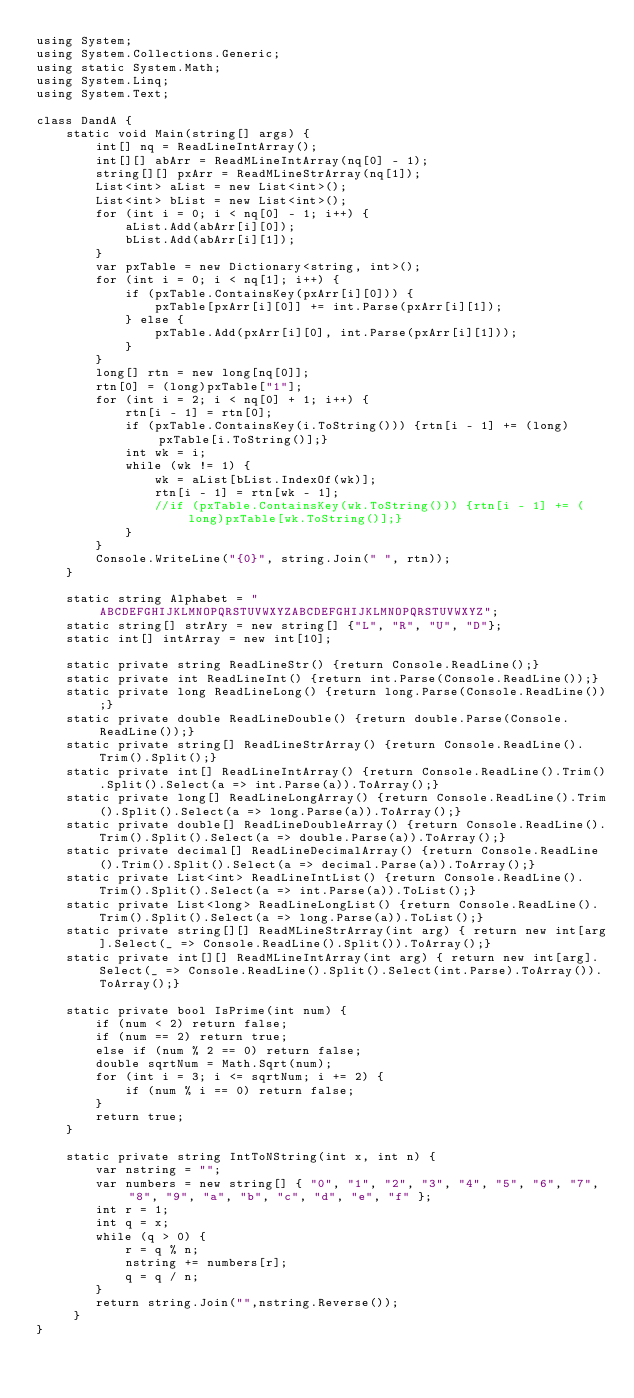Convert code to text. <code><loc_0><loc_0><loc_500><loc_500><_C#_>using System;
using System.Collections.Generic;
using static System.Math;
using System.Linq;
using System.Text;
 
class DandA {
    static void Main(string[] args) {
        int[] nq = ReadLineIntArray();
        int[][] abArr = ReadMLineIntArray(nq[0] - 1);
        string[][] pxArr = ReadMLineStrArray(nq[1]);
        List<int> aList = new List<int>();
        List<int> bList = new List<int>();
        for (int i = 0; i < nq[0] - 1; i++) {
            aList.Add(abArr[i][0]);
            bList.Add(abArr[i][1]);
        }
        var pxTable = new Dictionary<string, int>();
        for (int i = 0; i < nq[1]; i++) {
            if (pxTable.ContainsKey(pxArr[i][0])) {
                pxTable[pxArr[i][0]] += int.Parse(pxArr[i][1]);
            } else {
                pxTable.Add(pxArr[i][0], int.Parse(pxArr[i][1]));
            }
        }
        long[] rtn = new long[nq[0]];
        rtn[0] = (long)pxTable["1"];
        for (int i = 2; i < nq[0] + 1; i++) {
            rtn[i - 1] = rtn[0];
            if (pxTable.ContainsKey(i.ToString())) {rtn[i - 1] += (long)pxTable[i.ToString()];}
            int wk = i;
            while (wk != 1) {
                wk = aList[bList.IndexOf(wk)];
                rtn[i - 1] = rtn[wk - 1];
                //if (pxTable.ContainsKey(wk.ToString())) {rtn[i - 1] += (long)pxTable[wk.ToString()];}
            }
        }
        Console.WriteLine("{0}", string.Join(" ", rtn));
    }
 
    static string Alphabet = "ABCDEFGHIJKLMNOPQRSTUVWXYZABCDEFGHIJKLMNOPQRSTUVWXYZ";
    static string[] strAry = new string[] {"L", "R", "U", "D"};
    static int[] intArray = new int[10];
  
    static private string ReadLineStr() {return Console.ReadLine();}
    static private int ReadLineInt() {return int.Parse(Console.ReadLine());}
    static private long ReadLineLong() {return long.Parse(Console.ReadLine());}
    static private double ReadLineDouble() {return double.Parse(Console.ReadLine());}
    static private string[] ReadLineStrArray() {return Console.ReadLine().Trim().Split();}
    static private int[] ReadLineIntArray() {return Console.ReadLine().Trim().Split().Select(a => int.Parse(a)).ToArray();}
    static private long[] ReadLineLongArray() {return Console.ReadLine().Trim().Split().Select(a => long.Parse(a)).ToArray();}
    static private double[] ReadLineDoubleArray() {return Console.ReadLine().Trim().Split().Select(a => double.Parse(a)).ToArray();}
    static private decimal[] ReadLineDecimalArray() {return Console.ReadLine().Trim().Split().Select(a => decimal.Parse(a)).ToArray();}
    static private List<int> ReadLineIntList() {return Console.ReadLine().Trim().Split().Select(a => int.Parse(a)).ToList();}
    static private List<long> ReadLineLongList() {return Console.ReadLine().Trim().Split().Select(a => long.Parse(a)).ToList();}
    static private string[][] ReadMLineStrArray(int arg) { return new int[arg].Select(_ => Console.ReadLine().Split()).ToArray();}
    static private int[][] ReadMLineIntArray(int arg) { return new int[arg].Select(_ => Console.ReadLine().Split().Select(int.Parse).ToArray()).ToArray();}
 
    static private bool IsPrime(int num) {
        if (num < 2) return false;
        if (num == 2) return true;
        else if (num % 2 == 0) return false;
        double sqrtNum = Math.Sqrt(num);
        for (int i = 3; i <= sqrtNum; i += 2) {
            if (num % i == 0) return false;
        }
        return true;
    }
  
    static private string IntToNString(int x, int n) {
        var nstring = "";
        var numbers = new string[] { "0", "1", "2", "3", "4", "5", "6", "7", "8", "9", "a", "b", "c", "d", "e", "f" };
        int r = 1;
        int q = x;
        while (q > 0) {
            r = q % n;
            nstring += numbers[r];
            q = q / n;
        }
        return string.Join("",nstring.Reverse());
     }
}</code> 